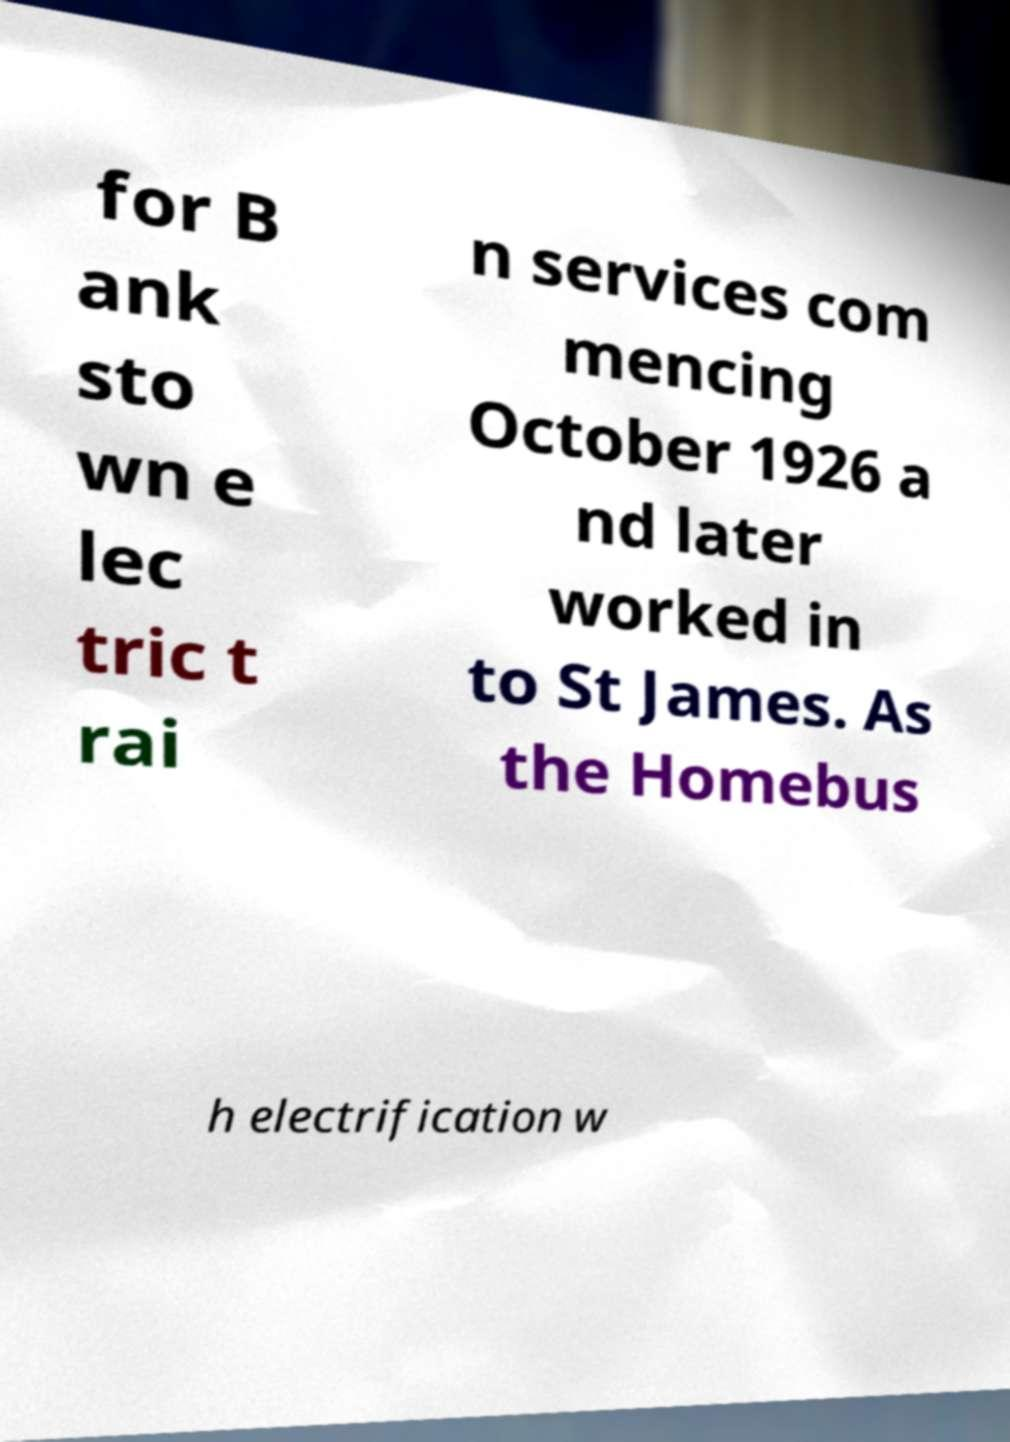Please identify and transcribe the text found in this image. for B ank sto wn e lec tric t rai n services com mencing October 1926 a nd later worked in to St James. As the Homebus h electrification w 